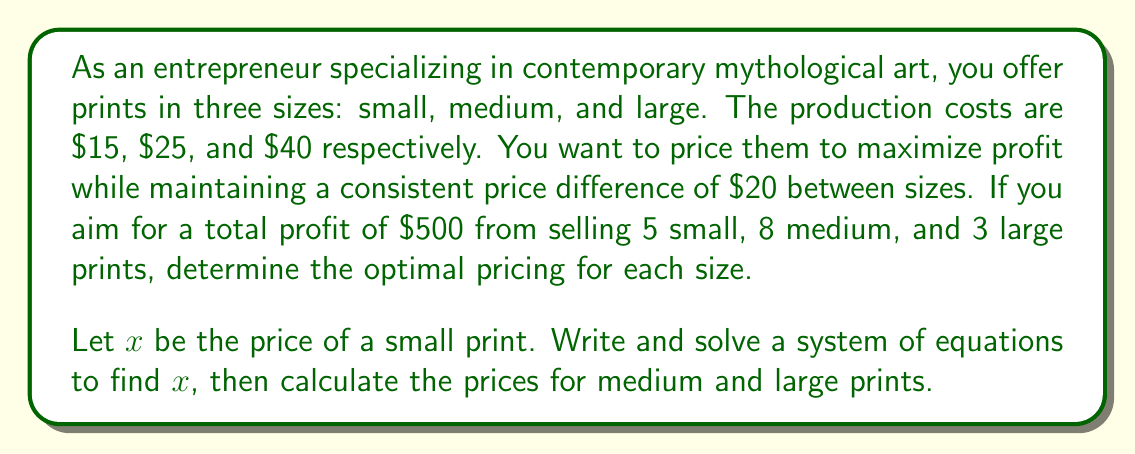Help me with this question. Let's approach this step-by-step:

1) Define variables:
   $x$ = price of small print
   $x + 20$ = price of medium print
   $x + 40$ = price of large print

2) Set up the profit equation:
   Profit = Revenue - Cost
   $500 = 5(x - 15) + 8((x+20) - 25) + 3((x+40) - 40)$

3) Simplify the equation:
   $500 = 5x - 75 + 8x + 160 - 200 + 3x + 120 - 120$
   $500 = 16x - 115$

4) Solve for $x$:
   $16x = 615$
   $x = 38.4375$

5) Round $x$ to the nearest whole dollar:
   $x = 38$

6) Calculate prices for medium and large prints:
   Medium: $38 + 20 = 58$
   Large: $38 + 40 = 78$

7) Verify the profit:
   Profit = $5(38 - 15) + 8(58 - 25) + 3(78 - 40)$
         = $5(23) + 8(33) + 3(38)$
         = $115 + 264 + 114$
         = $493$

   The slight discrepancy from $500 is due to rounding.
Answer: Small: $38, Medium: $58, Large: $78 